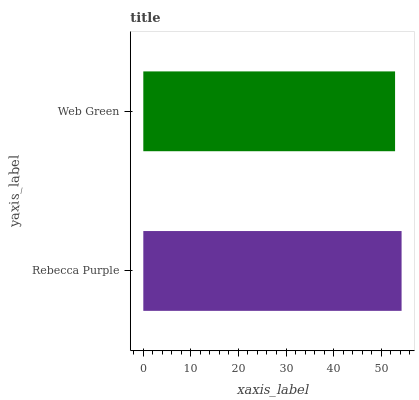Is Web Green the minimum?
Answer yes or no. Yes. Is Rebecca Purple the maximum?
Answer yes or no. Yes. Is Web Green the maximum?
Answer yes or no. No. Is Rebecca Purple greater than Web Green?
Answer yes or no. Yes. Is Web Green less than Rebecca Purple?
Answer yes or no. Yes. Is Web Green greater than Rebecca Purple?
Answer yes or no. No. Is Rebecca Purple less than Web Green?
Answer yes or no. No. Is Rebecca Purple the high median?
Answer yes or no. Yes. Is Web Green the low median?
Answer yes or no. Yes. Is Web Green the high median?
Answer yes or no. No. Is Rebecca Purple the low median?
Answer yes or no. No. 